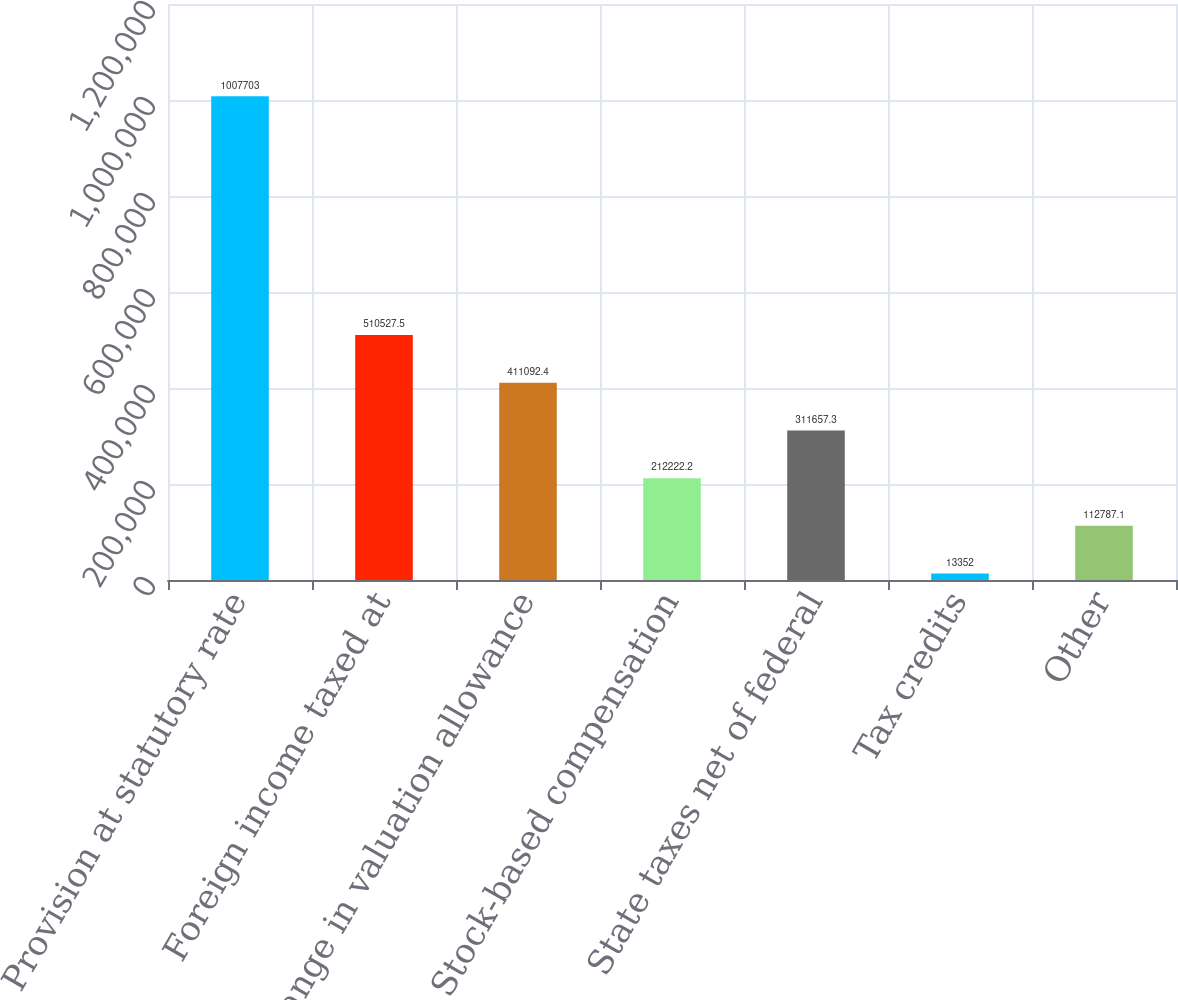Convert chart to OTSL. <chart><loc_0><loc_0><loc_500><loc_500><bar_chart><fcel>Provision at statutory rate<fcel>Foreign income taxed at<fcel>Change in valuation allowance<fcel>Stock-based compensation<fcel>State taxes net of federal<fcel>Tax credits<fcel>Other<nl><fcel>1.0077e+06<fcel>510528<fcel>411092<fcel>212222<fcel>311657<fcel>13352<fcel>112787<nl></chart> 